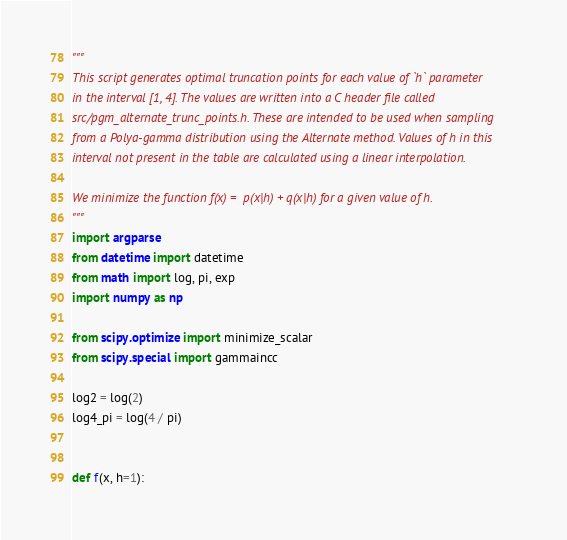Convert code to text. <code><loc_0><loc_0><loc_500><loc_500><_Python_>"""
This script generates optimal truncation points for each value of `h` parameter
in the interval [1, 4]. The values are written into a C header file called
src/pgm_alternate_trunc_points.h. These are intended to be used when sampling
from a Polya-gamma distribution using the Alternate method. Values of h in this
interval not present in the table are calculated using a linear interpolation.

We minimize the function f(x) =  p(x|h) + q(x|h) for a given value of h.
"""
import argparse
from datetime import datetime
from math import log, pi, exp
import numpy as np

from scipy.optimize import minimize_scalar
from scipy.special import gammaincc

log2 = log(2)
log4_pi = log(4 / pi)


def f(x, h=1):</code> 